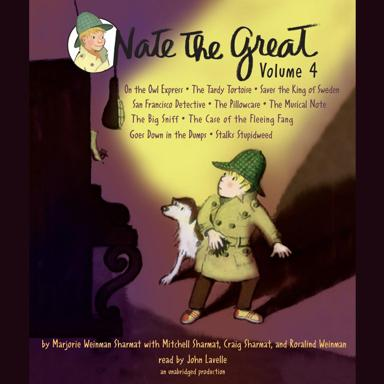Can you discuss the significance of the character's attire shown on the cover of 'Nate The Great Volume 4'? Certainly! Nate, depicted on the cover, wears a detective's trench coat and a Sherlock Holmes-style hat, symbolizing his role as a young, intrepid detective. This attire hints at the thematic elements of mystery and investigation that play central roles in the stories within this volume. 